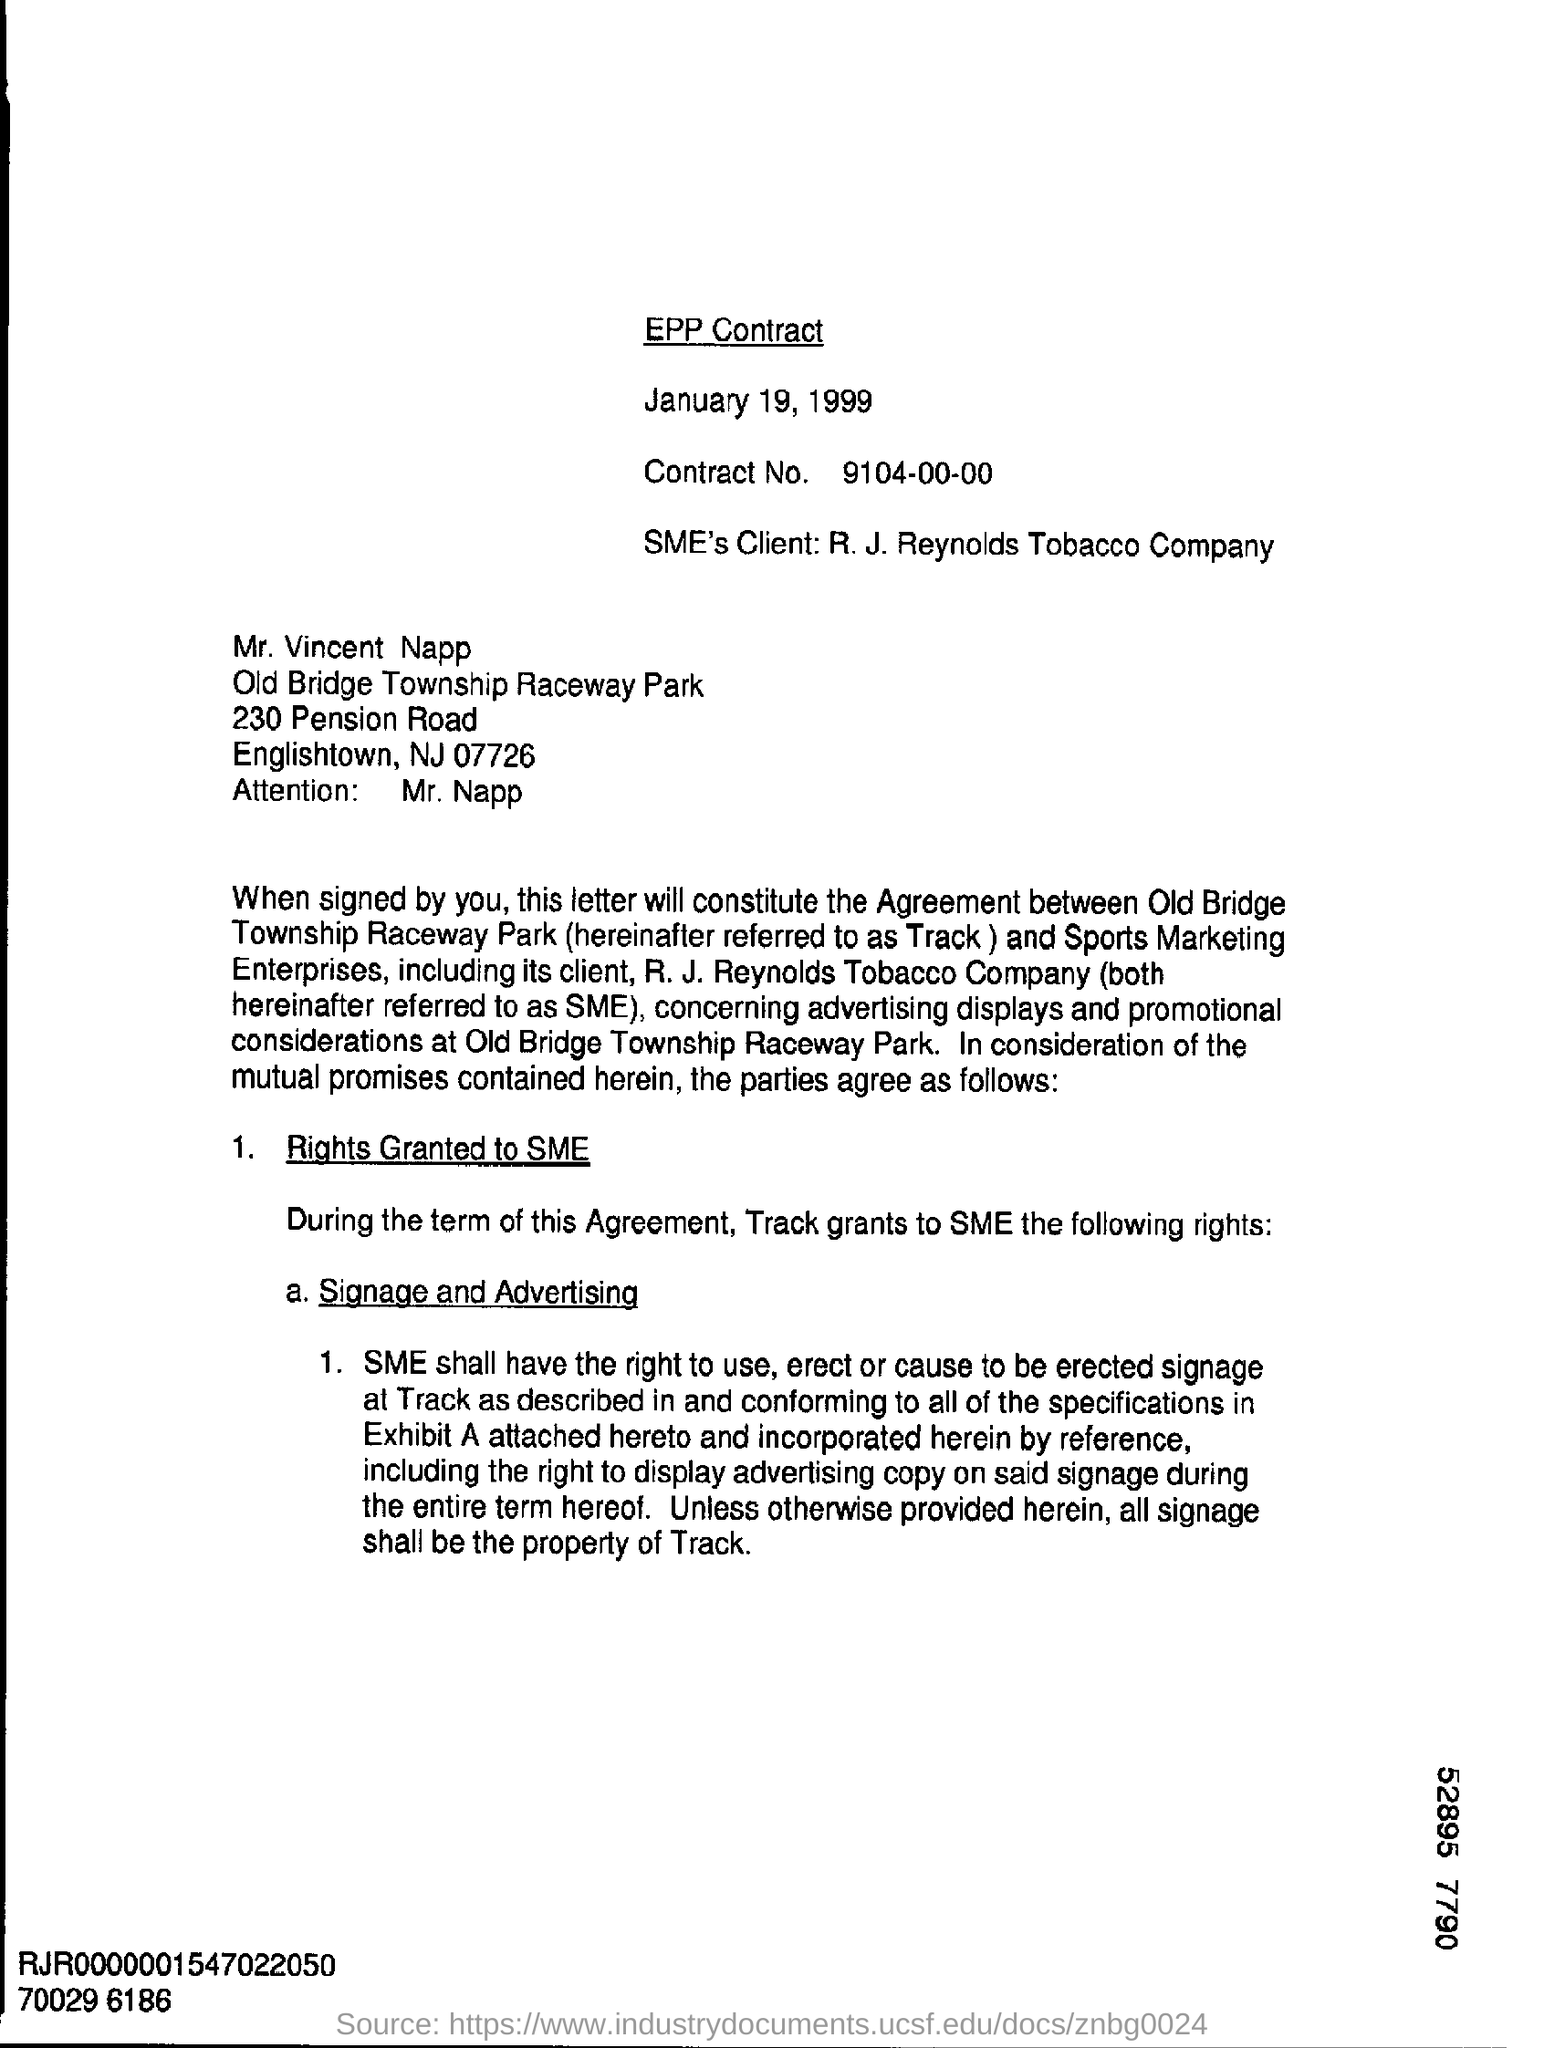Whose attention is invited in this letter?
 Mr. Napp 